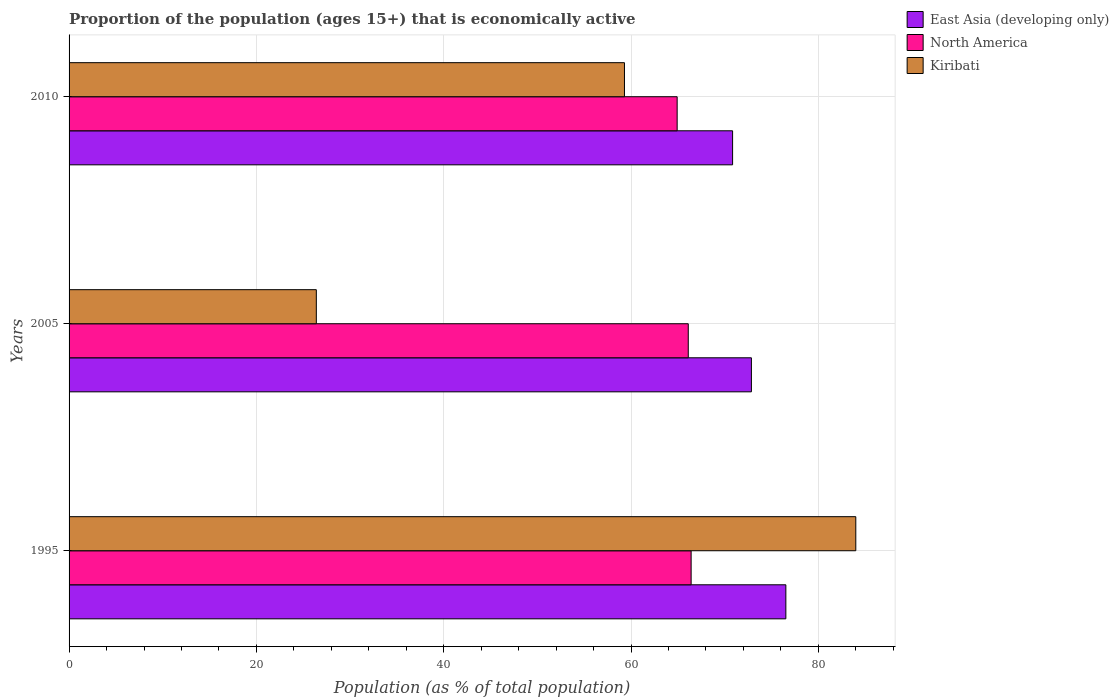How many different coloured bars are there?
Keep it short and to the point. 3. Are the number of bars per tick equal to the number of legend labels?
Provide a short and direct response. Yes. Are the number of bars on each tick of the Y-axis equal?
Offer a very short reply. Yes. How many bars are there on the 2nd tick from the top?
Offer a very short reply. 3. What is the label of the 3rd group of bars from the top?
Give a very brief answer. 1995. In how many cases, is the number of bars for a given year not equal to the number of legend labels?
Your answer should be compact. 0. What is the proportion of the population that is economically active in North America in 2010?
Keep it short and to the point. 64.93. Across all years, what is the maximum proportion of the population that is economically active in North America?
Your answer should be compact. 66.42. Across all years, what is the minimum proportion of the population that is economically active in North America?
Make the answer very short. 64.93. In which year was the proportion of the population that is economically active in Kiribati maximum?
Offer a terse response. 1995. What is the total proportion of the population that is economically active in Kiribati in the graph?
Provide a short and direct response. 169.7. What is the difference between the proportion of the population that is economically active in Kiribati in 1995 and that in 2010?
Keep it short and to the point. 24.7. What is the difference between the proportion of the population that is economically active in North America in 2005 and the proportion of the population that is economically active in East Asia (developing only) in 1995?
Make the answer very short. -10.42. What is the average proportion of the population that is economically active in North America per year?
Your answer should be very brief. 65.82. In the year 2010, what is the difference between the proportion of the population that is economically active in North America and proportion of the population that is economically active in Kiribati?
Make the answer very short. 5.63. In how many years, is the proportion of the population that is economically active in Kiribati greater than 68 %?
Your answer should be very brief. 1. What is the ratio of the proportion of the population that is economically active in North America in 2005 to that in 2010?
Your answer should be very brief. 1.02. Is the difference between the proportion of the population that is economically active in North America in 2005 and 2010 greater than the difference between the proportion of the population that is economically active in Kiribati in 2005 and 2010?
Provide a succinct answer. Yes. What is the difference between the highest and the second highest proportion of the population that is economically active in North America?
Ensure brevity in your answer.  0.31. What is the difference between the highest and the lowest proportion of the population that is economically active in Kiribati?
Keep it short and to the point. 57.6. In how many years, is the proportion of the population that is economically active in Kiribati greater than the average proportion of the population that is economically active in Kiribati taken over all years?
Ensure brevity in your answer.  2. Is the sum of the proportion of the population that is economically active in East Asia (developing only) in 1995 and 2010 greater than the maximum proportion of the population that is economically active in North America across all years?
Keep it short and to the point. Yes. What does the 2nd bar from the top in 2005 represents?
Keep it short and to the point. North America. What does the 3rd bar from the bottom in 2005 represents?
Your answer should be very brief. Kiribati. What is the difference between two consecutive major ticks on the X-axis?
Your response must be concise. 20. Are the values on the major ticks of X-axis written in scientific E-notation?
Your answer should be compact. No. Where does the legend appear in the graph?
Make the answer very short. Top right. How many legend labels are there?
Provide a short and direct response. 3. How are the legend labels stacked?
Your answer should be compact. Vertical. What is the title of the graph?
Offer a very short reply. Proportion of the population (ages 15+) that is economically active. What is the label or title of the X-axis?
Make the answer very short. Population (as % of total population). What is the Population (as % of total population) in East Asia (developing only) in 1995?
Keep it short and to the point. 76.53. What is the Population (as % of total population) in North America in 1995?
Make the answer very short. 66.42. What is the Population (as % of total population) in Kiribati in 1995?
Give a very brief answer. 84. What is the Population (as % of total population) in East Asia (developing only) in 2005?
Offer a very short reply. 72.85. What is the Population (as % of total population) in North America in 2005?
Give a very brief answer. 66.11. What is the Population (as % of total population) in Kiribati in 2005?
Keep it short and to the point. 26.4. What is the Population (as % of total population) of East Asia (developing only) in 2010?
Ensure brevity in your answer.  70.84. What is the Population (as % of total population) of North America in 2010?
Your answer should be compact. 64.93. What is the Population (as % of total population) of Kiribati in 2010?
Offer a very short reply. 59.3. Across all years, what is the maximum Population (as % of total population) in East Asia (developing only)?
Offer a very short reply. 76.53. Across all years, what is the maximum Population (as % of total population) in North America?
Your answer should be compact. 66.42. Across all years, what is the minimum Population (as % of total population) in East Asia (developing only)?
Your answer should be compact. 70.84. Across all years, what is the minimum Population (as % of total population) in North America?
Provide a succinct answer. 64.93. Across all years, what is the minimum Population (as % of total population) in Kiribati?
Offer a very short reply. 26.4. What is the total Population (as % of total population) in East Asia (developing only) in the graph?
Ensure brevity in your answer.  220.23. What is the total Population (as % of total population) of North America in the graph?
Keep it short and to the point. 197.46. What is the total Population (as % of total population) in Kiribati in the graph?
Your response must be concise. 169.7. What is the difference between the Population (as % of total population) in East Asia (developing only) in 1995 and that in 2005?
Your answer should be compact. 3.68. What is the difference between the Population (as % of total population) of North America in 1995 and that in 2005?
Make the answer very short. 0.31. What is the difference between the Population (as % of total population) of Kiribati in 1995 and that in 2005?
Keep it short and to the point. 57.6. What is the difference between the Population (as % of total population) in East Asia (developing only) in 1995 and that in 2010?
Provide a succinct answer. 5.69. What is the difference between the Population (as % of total population) in North America in 1995 and that in 2010?
Keep it short and to the point. 1.49. What is the difference between the Population (as % of total population) of Kiribati in 1995 and that in 2010?
Offer a very short reply. 24.7. What is the difference between the Population (as % of total population) of East Asia (developing only) in 2005 and that in 2010?
Your answer should be very brief. 2.01. What is the difference between the Population (as % of total population) of North America in 2005 and that in 2010?
Provide a succinct answer. 1.19. What is the difference between the Population (as % of total population) of Kiribati in 2005 and that in 2010?
Keep it short and to the point. -32.9. What is the difference between the Population (as % of total population) in East Asia (developing only) in 1995 and the Population (as % of total population) in North America in 2005?
Give a very brief answer. 10.42. What is the difference between the Population (as % of total population) of East Asia (developing only) in 1995 and the Population (as % of total population) of Kiribati in 2005?
Your answer should be compact. 50.13. What is the difference between the Population (as % of total population) of North America in 1995 and the Population (as % of total population) of Kiribati in 2005?
Keep it short and to the point. 40.02. What is the difference between the Population (as % of total population) of East Asia (developing only) in 1995 and the Population (as % of total population) of North America in 2010?
Keep it short and to the point. 11.61. What is the difference between the Population (as % of total population) in East Asia (developing only) in 1995 and the Population (as % of total population) in Kiribati in 2010?
Your response must be concise. 17.23. What is the difference between the Population (as % of total population) of North America in 1995 and the Population (as % of total population) of Kiribati in 2010?
Provide a succinct answer. 7.12. What is the difference between the Population (as % of total population) in East Asia (developing only) in 2005 and the Population (as % of total population) in North America in 2010?
Make the answer very short. 7.93. What is the difference between the Population (as % of total population) in East Asia (developing only) in 2005 and the Population (as % of total population) in Kiribati in 2010?
Offer a terse response. 13.55. What is the difference between the Population (as % of total population) in North America in 2005 and the Population (as % of total population) in Kiribati in 2010?
Give a very brief answer. 6.81. What is the average Population (as % of total population) in East Asia (developing only) per year?
Your response must be concise. 73.41. What is the average Population (as % of total population) of North America per year?
Provide a short and direct response. 65.82. What is the average Population (as % of total population) in Kiribati per year?
Keep it short and to the point. 56.57. In the year 1995, what is the difference between the Population (as % of total population) in East Asia (developing only) and Population (as % of total population) in North America?
Offer a very short reply. 10.11. In the year 1995, what is the difference between the Population (as % of total population) of East Asia (developing only) and Population (as % of total population) of Kiribati?
Your response must be concise. -7.47. In the year 1995, what is the difference between the Population (as % of total population) of North America and Population (as % of total population) of Kiribati?
Provide a succinct answer. -17.58. In the year 2005, what is the difference between the Population (as % of total population) in East Asia (developing only) and Population (as % of total population) in North America?
Provide a succinct answer. 6.74. In the year 2005, what is the difference between the Population (as % of total population) in East Asia (developing only) and Population (as % of total population) in Kiribati?
Give a very brief answer. 46.45. In the year 2005, what is the difference between the Population (as % of total population) of North America and Population (as % of total population) of Kiribati?
Your response must be concise. 39.71. In the year 2010, what is the difference between the Population (as % of total population) in East Asia (developing only) and Population (as % of total population) in North America?
Make the answer very short. 5.92. In the year 2010, what is the difference between the Population (as % of total population) of East Asia (developing only) and Population (as % of total population) of Kiribati?
Make the answer very short. 11.54. In the year 2010, what is the difference between the Population (as % of total population) in North America and Population (as % of total population) in Kiribati?
Your response must be concise. 5.63. What is the ratio of the Population (as % of total population) of East Asia (developing only) in 1995 to that in 2005?
Offer a terse response. 1.05. What is the ratio of the Population (as % of total population) of North America in 1995 to that in 2005?
Offer a very short reply. 1. What is the ratio of the Population (as % of total population) of Kiribati in 1995 to that in 2005?
Your response must be concise. 3.18. What is the ratio of the Population (as % of total population) in East Asia (developing only) in 1995 to that in 2010?
Your answer should be very brief. 1.08. What is the ratio of the Population (as % of total population) of North America in 1995 to that in 2010?
Make the answer very short. 1.02. What is the ratio of the Population (as % of total population) of Kiribati in 1995 to that in 2010?
Offer a terse response. 1.42. What is the ratio of the Population (as % of total population) in East Asia (developing only) in 2005 to that in 2010?
Provide a succinct answer. 1.03. What is the ratio of the Population (as % of total population) of North America in 2005 to that in 2010?
Give a very brief answer. 1.02. What is the ratio of the Population (as % of total population) of Kiribati in 2005 to that in 2010?
Provide a succinct answer. 0.45. What is the difference between the highest and the second highest Population (as % of total population) of East Asia (developing only)?
Make the answer very short. 3.68. What is the difference between the highest and the second highest Population (as % of total population) of North America?
Your response must be concise. 0.31. What is the difference between the highest and the second highest Population (as % of total population) in Kiribati?
Offer a terse response. 24.7. What is the difference between the highest and the lowest Population (as % of total population) of East Asia (developing only)?
Provide a succinct answer. 5.69. What is the difference between the highest and the lowest Population (as % of total population) in North America?
Your response must be concise. 1.49. What is the difference between the highest and the lowest Population (as % of total population) in Kiribati?
Provide a short and direct response. 57.6. 